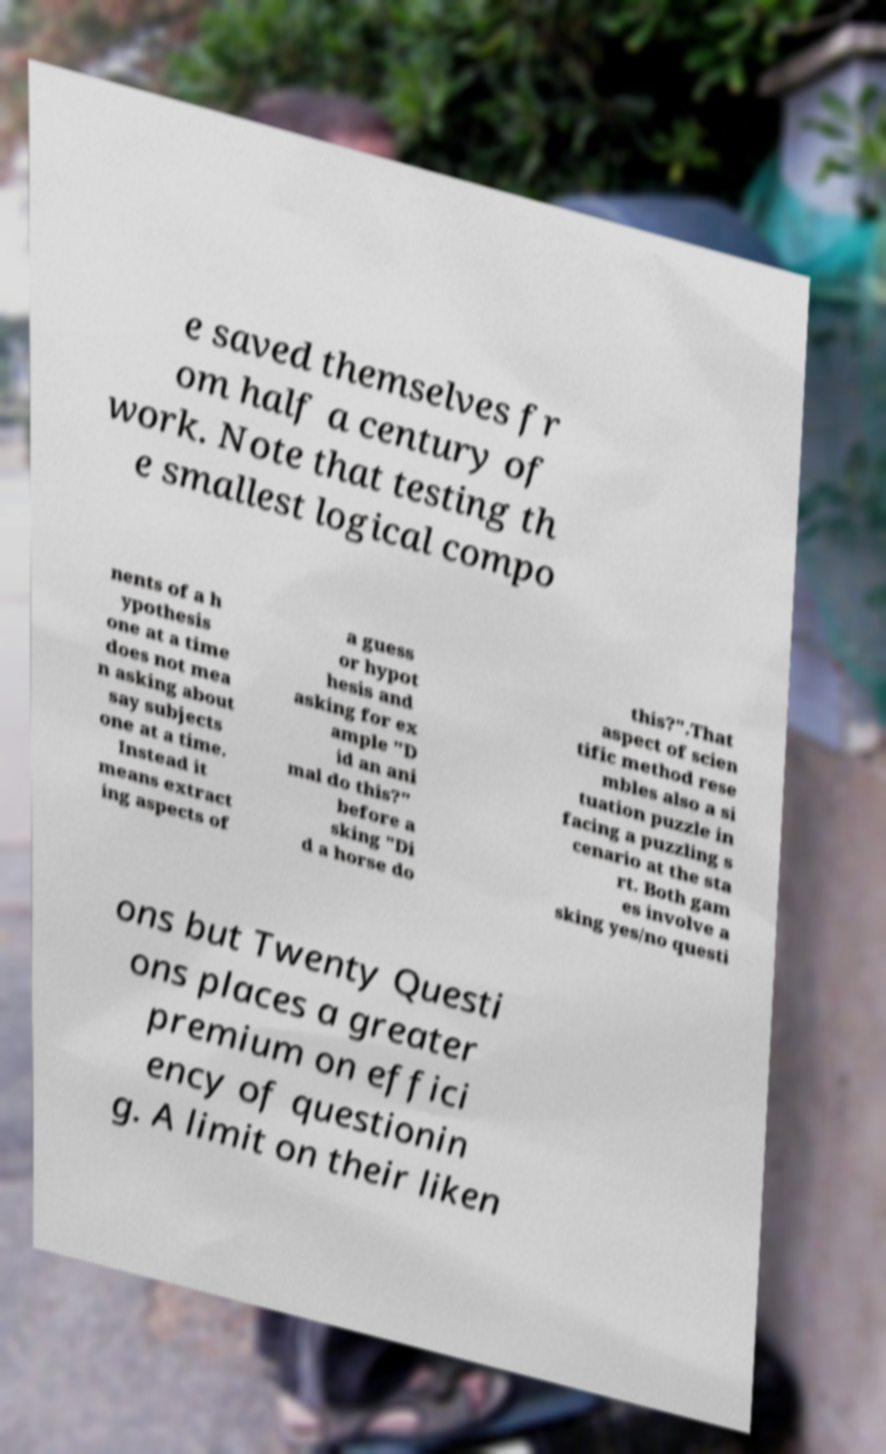There's text embedded in this image that I need extracted. Can you transcribe it verbatim? e saved themselves fr om half a century of work. Note that testing th e smallest logical compo nents of a h ypothesis one at a time does not mea n asking about say subjects one at a time. Instead it means extract ing aspects of a guess or hypot hesis and asking for ex ample "D id an ani mal do this?" before a sking "Di d a horse do this?".That aspect of scien tific method rese mbles also a si tuation puzzle in facing a puzzling s cenario at the sta rt. Both gam es involve a sking yes/no questi ons but Twenty Questi ons places a greater premium on effici ency of questionin g. A limit on their liken 